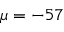Convert formula to latex. <formula><loc_0><loc_0><loc_500><loc_500>\mu = - 5 7</formula> 